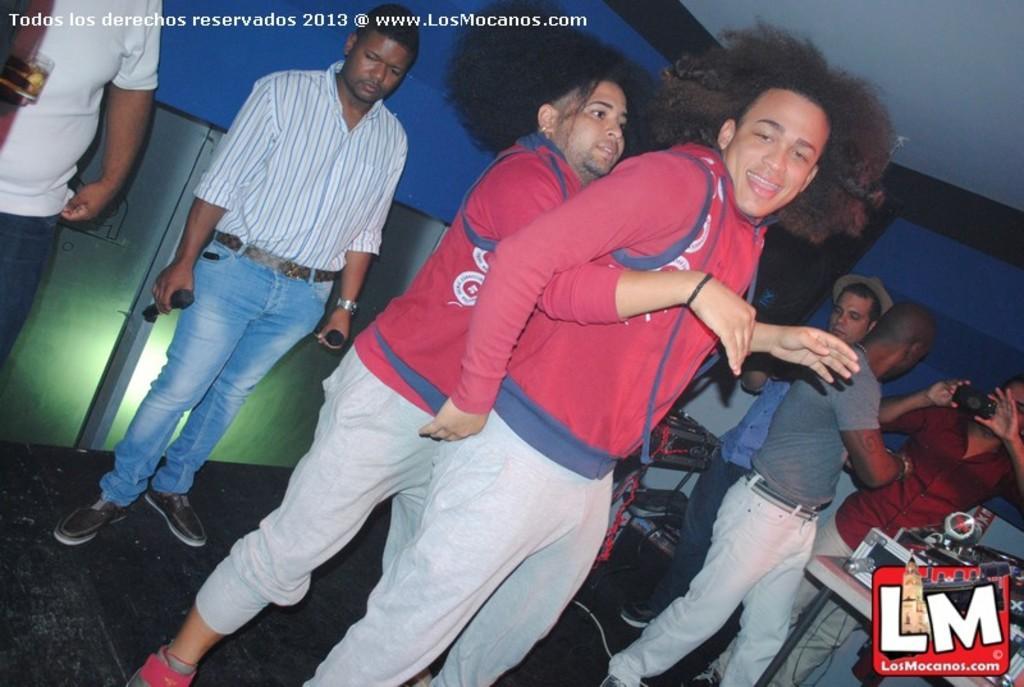Can you describe this image briefly? In this image we can see a person's dancing on the floor. In the background there are musical instruments, group of persons, wall and ceiling. 